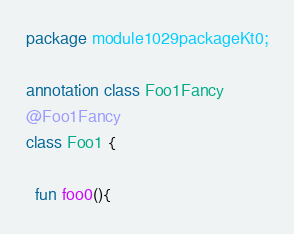<code> <loc_0><loc_0><loc_500><loc_500><_Kotlin_>package module1029packageKt0;

annotation class Foo1Fancy
@Foo1Fancy
class Foo1 {

  fun foo0(){</code> 